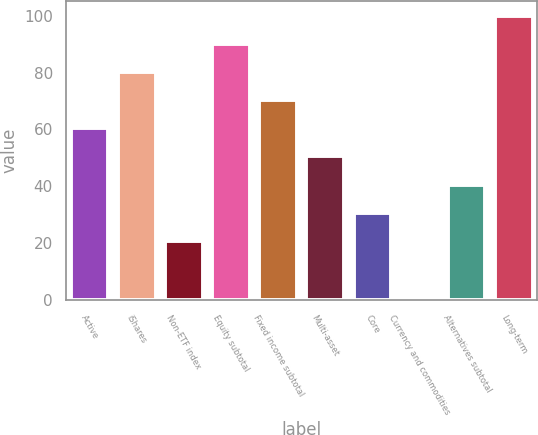Convert chart to OTSL. <chart><loc_0><loc_0><loc_500><loc_500><bar_chart><fcel>Active<fcel>iShares<fcel>Non-ETF index<fcel>Equity subtotal<fcel>Fixed income subtotal<fcel>Multi-asset<fcel>Core<fcel>Currency and commodities<fcel>Alternatives subtotal<fcel>Long-term<nl><fcel>60.4<fcel>80.2<fcel>20.8<fcel>90.1<fcel>70.3<fcel>50.5<fcel>30.7<fcel>1<fcel>40.6<fcel>100<nl></chart> 